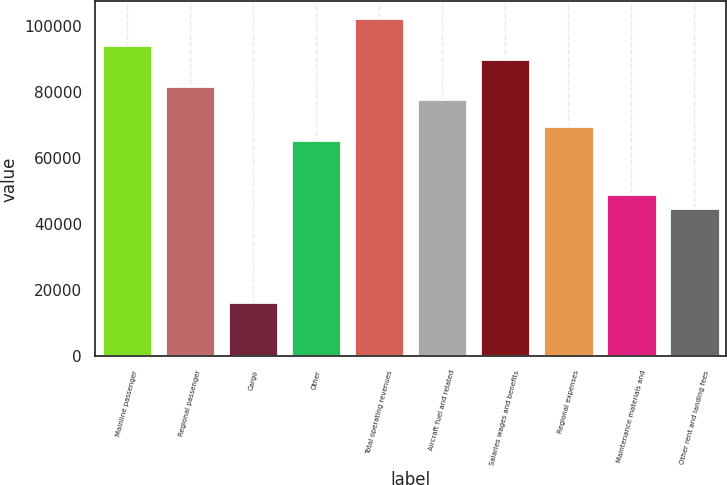<chart> <loc_0><loc_0><loc_500><loc_500><bar_chart><fcel>Mainline passenger<fcel>Regional passenger<fcel>Cargo<fcel>Other<fcel>Total operating revenues<fcel>Aircraft fuel and related<fcel>Salaries wages and benefits<fcel>Regional expenses<fcel>Maintenance materials and<fcel>Other rent and landing fees<nl><fcel>94262.5<fcel>81968.9<fcel>16402.6<fcel>65577.3<fcel>102458<fcel>77871<fcel>90164.6<fcel>69675.2<fcel>49185.8<fcel>45087.9<nl></chart> 